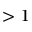Convert formula to latex. <formula><loc_0><loc_0><loc_500><loc_500>> 1</formula> 